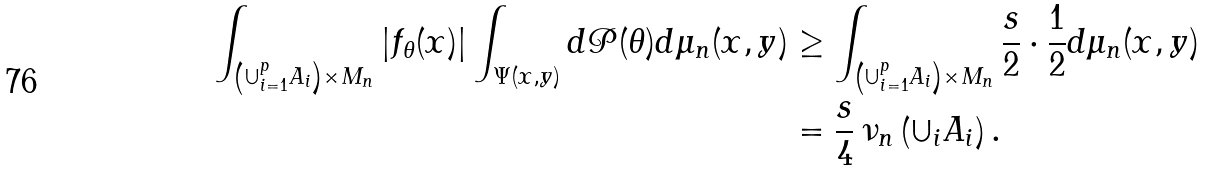Convert formula to latex. <formula><loc_0><loc_0><loc_500><loc_500>\int _ { \left ( \cup _ { i = 1 } ^ { p } A _ { i } \right ) \times M _ { n } } | f _ { \theta } ( x ) | \int _ { \Psi ( x , y ) } d \mathcal { P } ( \theta ) d \mu _ { n } ( x , y ) & \geq \int _ { \left ( \cup _ { i = 1 } ^ { p } A _ { i } \right ) \times M _ { n } } \frac { s } { 2 } \cdot \frac { 1 } { 2 } d \mu _ { n } ( x , y ) \\ & = \frac { s } { 4 } \, \nu _ { n } \left ( \cup _ { i } A _ { i } \right ) .</formula> 